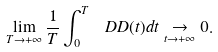<formula> <loc_0><loc_0><loc_500><loc_500>\lim _ { T \rightarrow + \infty } \frac { 1 } { T } \int _ { 0 } ^ { T } \ D D ( t ) d t \underset { t \rightarrow + \infty } { \rightarrow } 0 .</formula> 